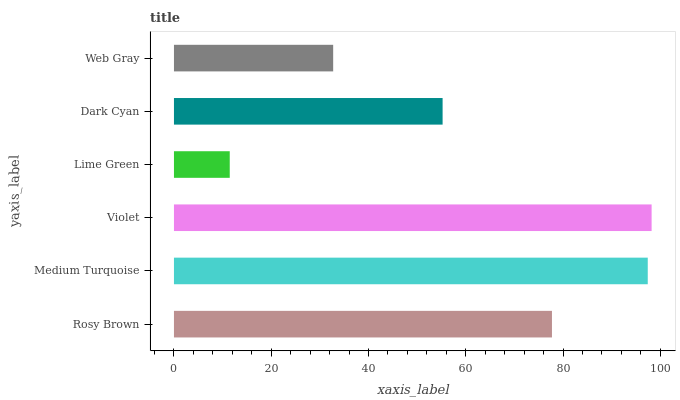Is Lime Green the minimum?
Answer yes or no. Yes. Is Violet the maximum?
Answer yes or no. Yes. Is Medium Turquoise the minimum?
Answer yes or no. No. Is Medium Turquoise the maximum?
Answer yes or no. No. Is Medium Turquoise greater than Rosy Brown?
Answer yes or no. Yes. Is Rosy Brown less than Medium Turquoise?
Answer yes or no. Yes. Is Rosy Brown greater than Medium Turquoise?
Answer yes or no. No. Is Medium Turquoise less than Rosy Brown?
Answer yes or no. No. Is Rosy Brown the high median?
Answer yes or no. Yes. Is Dark Cyan the low median?
Answer yes or no. Yes. Is Medium Turquoise the high median?
Answer yes or no. No. Is Rosy Brown the low median?
Answer yes or no. No. 